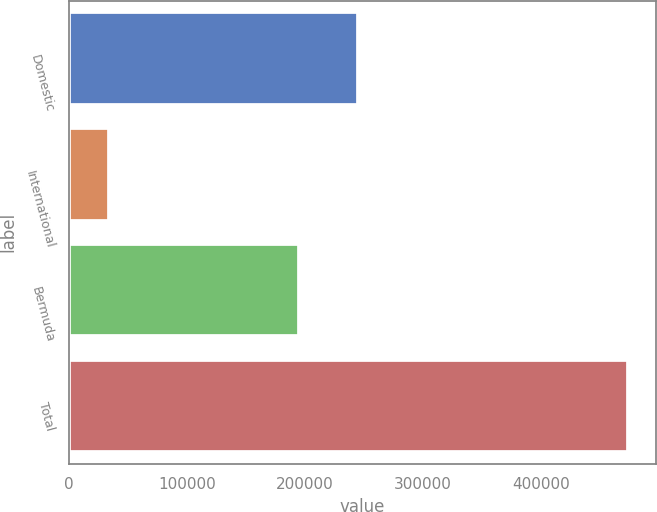Convert chart. <chart><loc_0><loc_0><loc_500><loc_500><bar_chart><fcel>Domestic<fcel>International<fcel>Bermuda<fcel>Total<nl><fcel>245159<fcel>34181<fcel>194485<fcel>473825<nl></chart> 